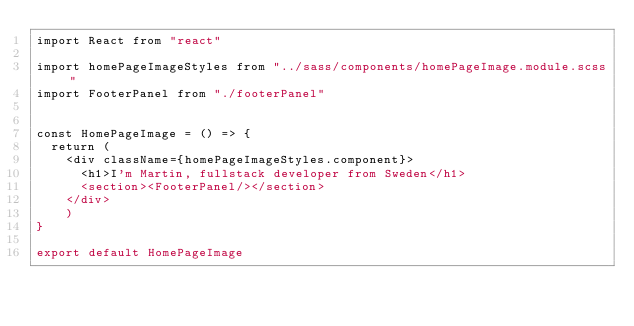<code> <loc_0><loc_0><loc_500><loc_500><_JavaScript_>import React from "react"

import homePageImageStyles from "../sass/components/homePageImage.module.scss"
import FooterPanel from "./footerPanel"


const HomePageImage = () => {
  return (
    <div className={homePageImageStyles.component}>
      <h1>I'm Martin, fullstack developer from Sweden</h1>
      <section><FooterPanel/></section>
    </div>
    )
}

export default HomePageImage
</code> 